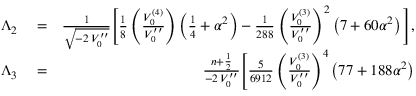<formula> <loc_0><loc_0><loc_500><loc_500>\begin{array} { r l r } { \Lambda _ { 2 } } & = } & { \frac { 1 } { \sqrt { - 2 \, V _ { 0 } ^ { \prime \prime } } } \Big [ \frac { 1 } { 8 } \left ( \frac { V _ { 0 } ^ { ( 4 ) } } { V _ { 0 } ^ { \prime \prime } } \right ) \left ( \frac { 1 } { 4 } + \alpha ^ { 2 } \right ) - \frac { 1 } { 2 8 8 } \left ( \frac { V _ { 0 } ^ { ( 3 ) } } { V _ { 0 } ^ { \prime \prime } } \right ) ^ { 2 } \left ( 7 + 6 0 \alpha ^ { 2 } \right ) \Big ] , } \\ { \Lambda _ { 3 } } & = } & { \frac { n + \frac { 1 } { 2 } } { - 2 \, V _ { 0 } ^ { \prime \prime } } \Big [ \frac { 5 } { 6 9 1 2 } \left ( \frac { V _ { 0 } ^ { ( 3 ) } } { V _ { 0 } ^ { \prime \prime } } \right ) ^ { 4 } \left ( 7 7 + 1 8 8 \alpha ^ { 2 } \right ) } \end{array}</formula> 